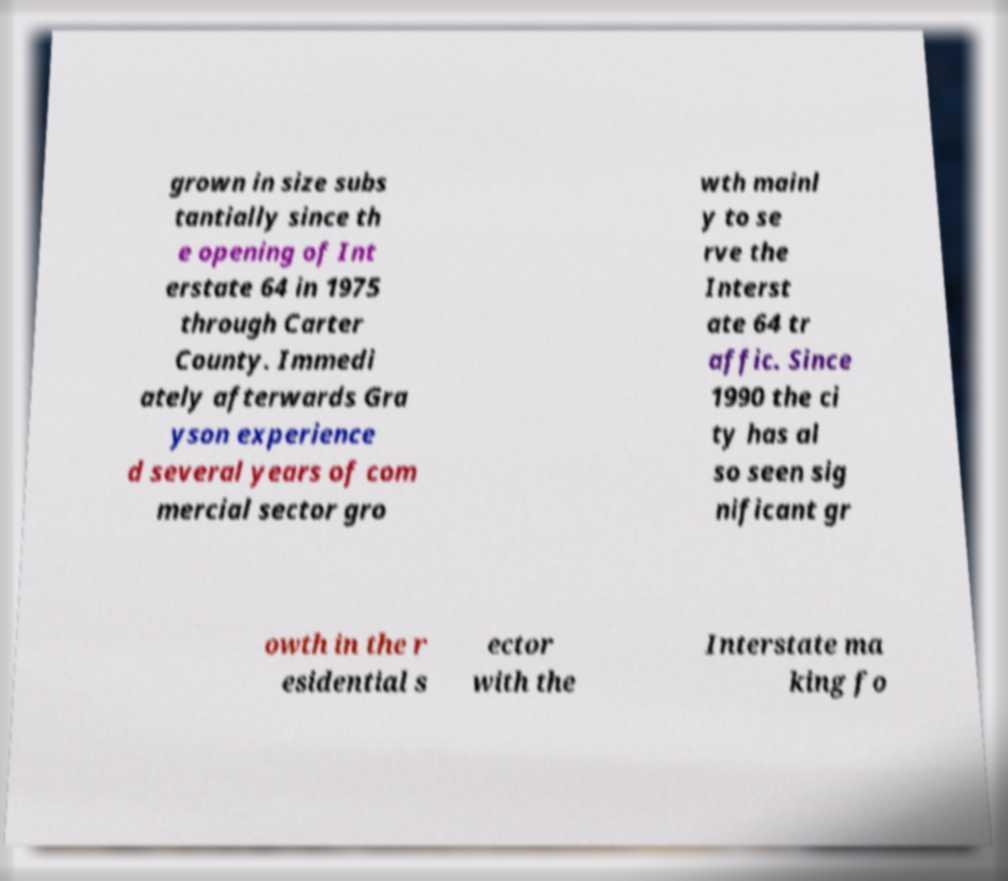Could you assist in decoding the text presented in this image and type it out clearly? grown in size subs tantially since th e opening of Int erstate 64 in 1975 through Carter County. Immedi ately afterwards Gra yson experience d several years of com mercial sector gro wth mainl y to se rve the Interst ate 64 tr affic. Since 1990 the ci ty has al so seen sig nificant gr owth in the r esidential s ector with the Interstate ma king fo 